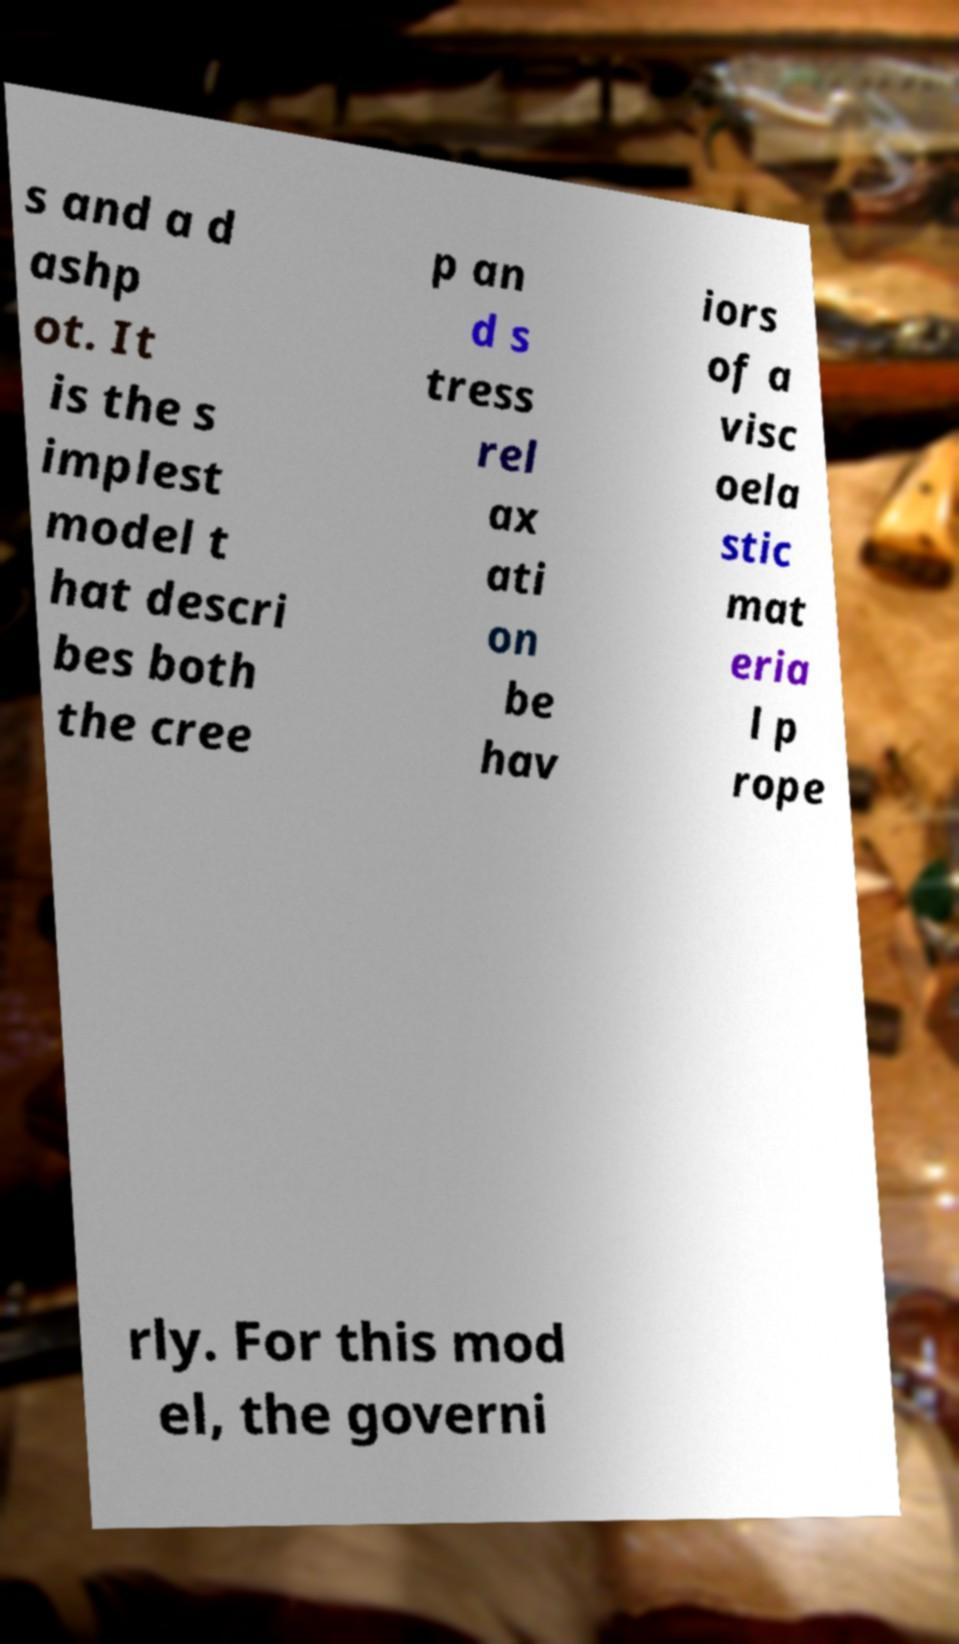There's text embedded in this image that I need extracted. Can you transcribe it verbatim? s and a d ashp ot. It is the s implest model t hat descri bes both the cree p an d s tress rel ax ati on be hav iors of a visc oela stic mat eria l p rope rly. For this mod el, the governi 